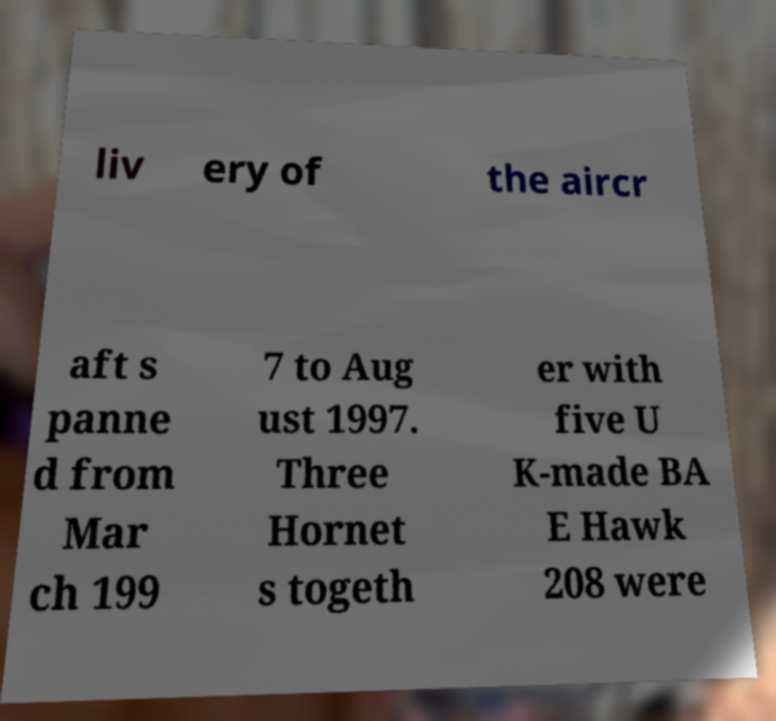I need the written content from this picture converted into text. Can you do that? liv ery of the aircr aft s panne d from Mar ch 199 7 to Aug ust 1997. Three Hornet s togeth er with five U K-made BA E Hawk 208 were 